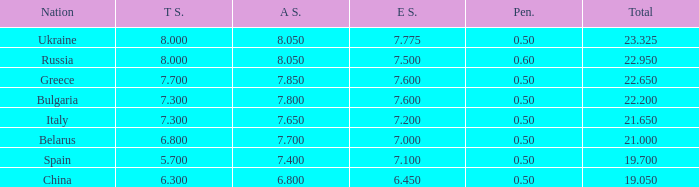What's the sum of A Score that also has a score lower than 7.3 and an E Score larger than 7.1? None. 